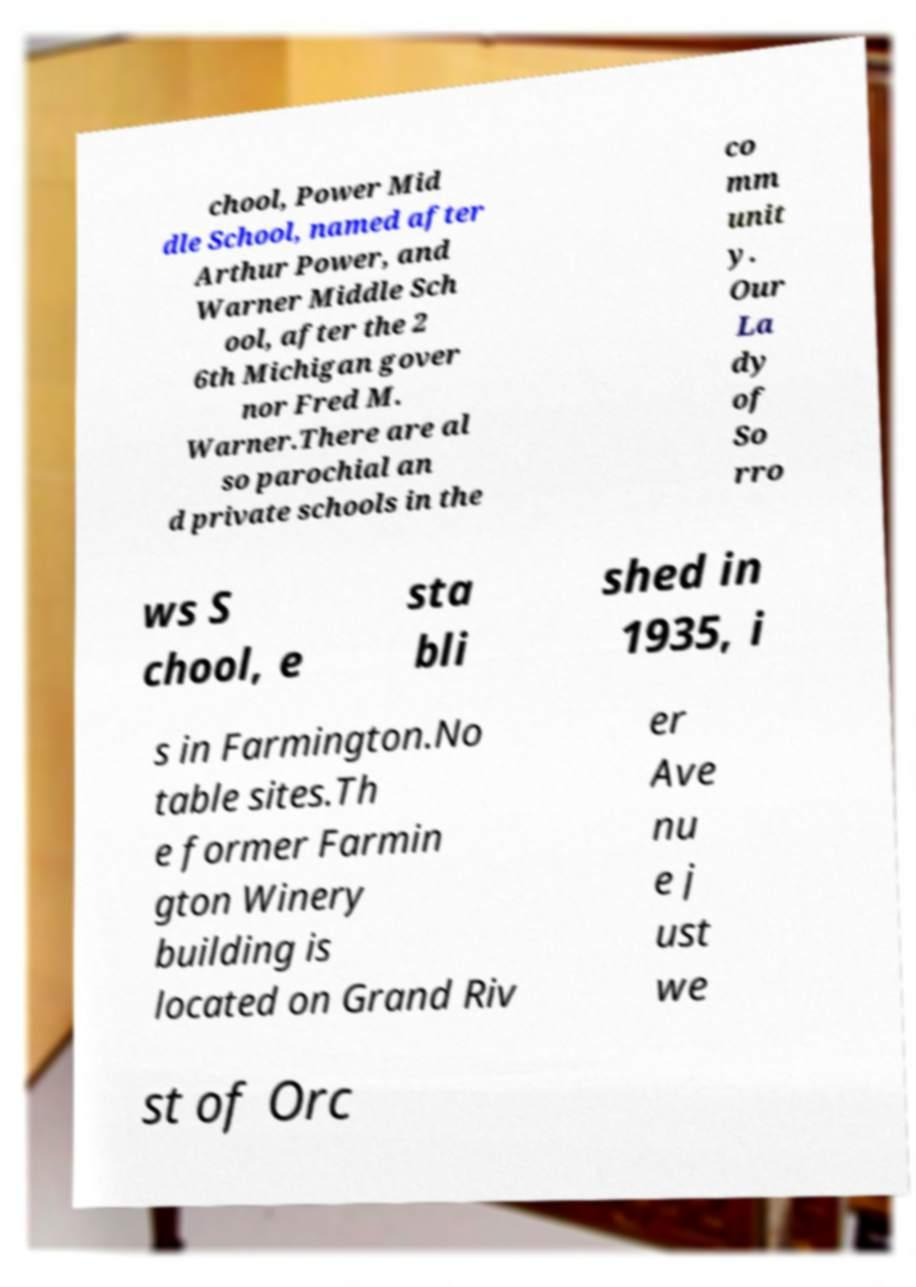Please read and relay the text visible in this image. What does it say? chool, Power Mid dle School, named after Arthur Power, and Warner Middle Sch ool, after the 2 6th Michigan gover nor Fred M. Warner.There are al so parochial an d private schools in the co mm unit y. Our La dy of So rro ws S chool, e sta bli shed in 1935, i s in Farmington.No table sites.Th e former Farmin gton Winery building is located on Grand Riv er Ave nu e j ust we st of Orc 